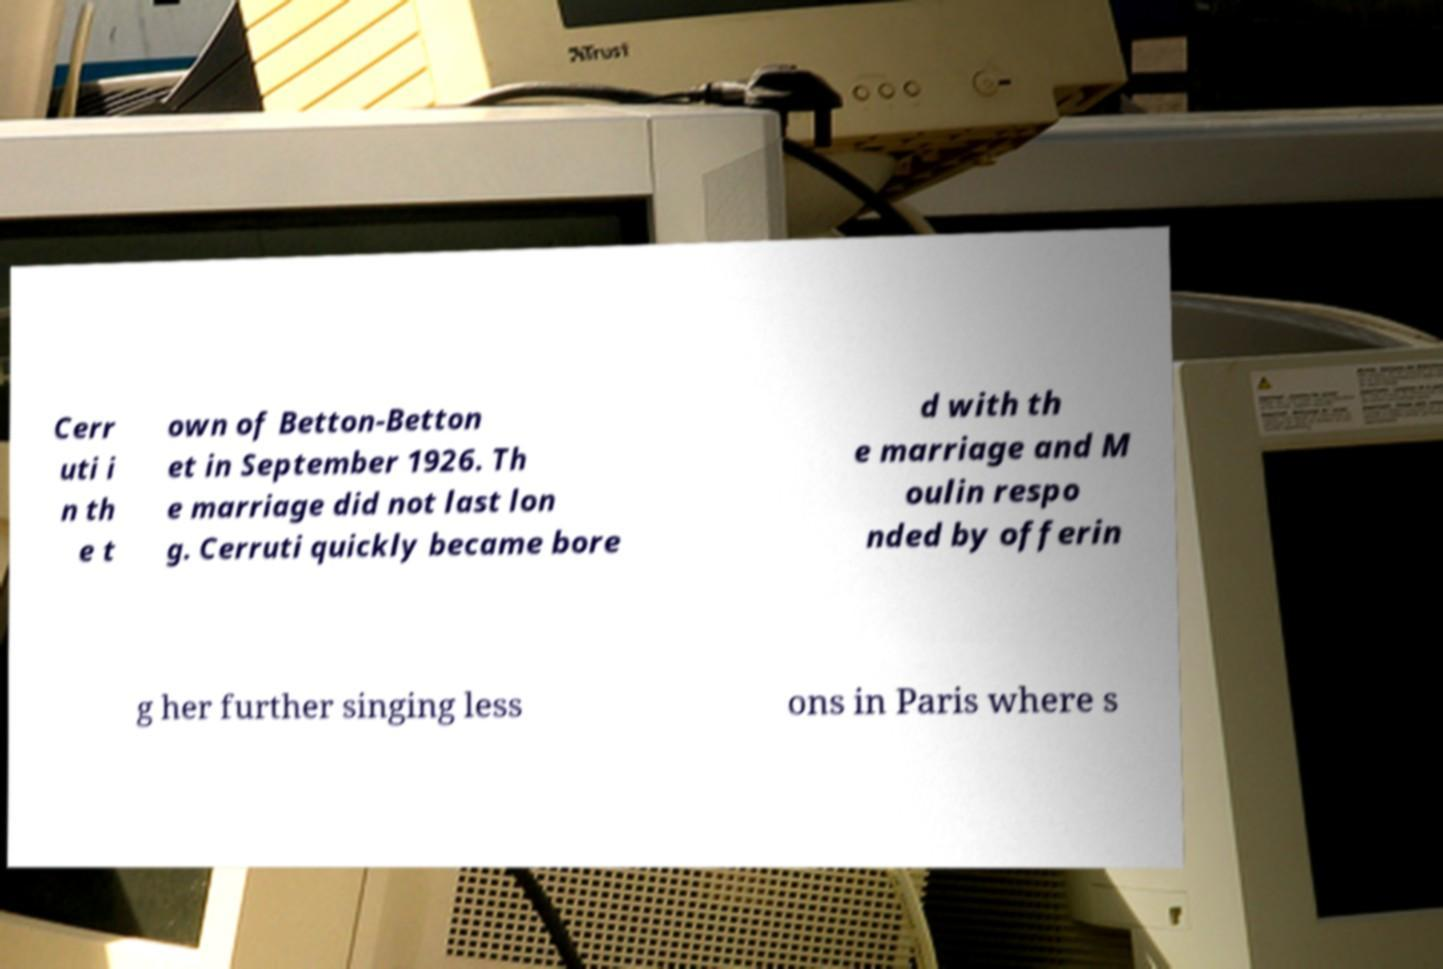Can you read and provide the text displayed in the image?This photo seems to have some interesting text. Can you extract and type it out for me? Cerr uti i n th e t own of Betton-Betton et in September 1926. Th e marriage did not last lon g. Cerruti quickly became bore d with th e marriage and M oulin respo nded by offerin g her further singing less ons in Paris where s 